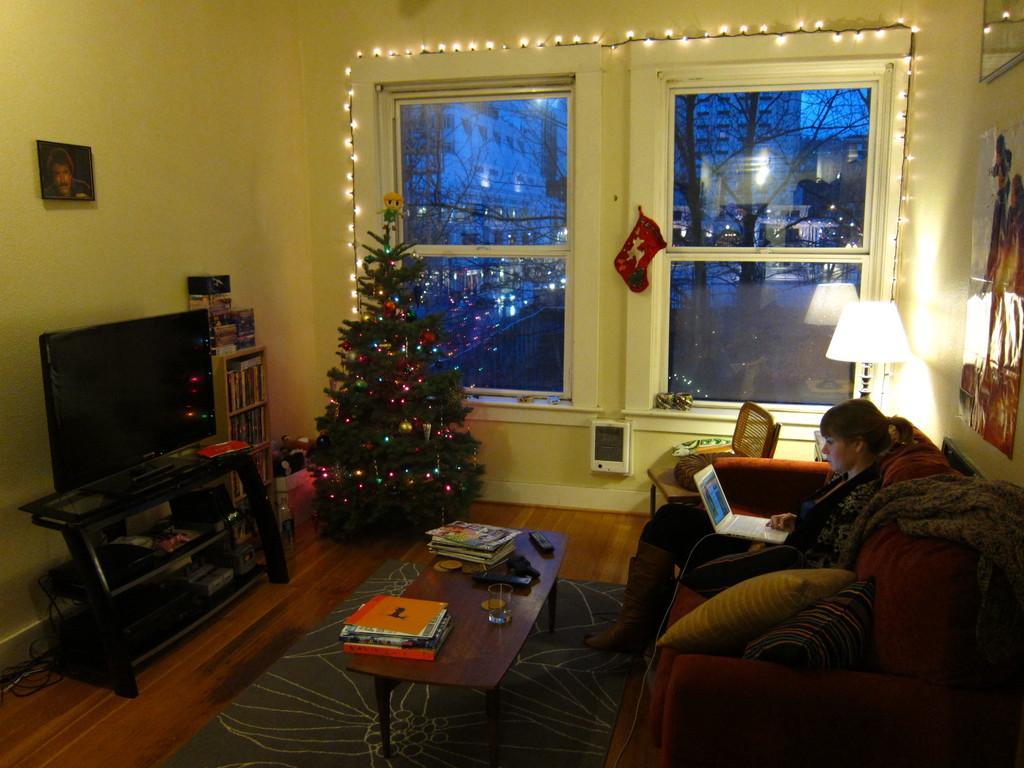Could you give a brief overview of what you see in this image? In the middle of the image there is a xmas tree. Bottom middle of the image there is a table, On the table there is a glass and there are some books. Top right side of the image there is a wall on the wall there are some frames. Bottom right side of the image there is couch, On the couch there is a woman sitting and looking in to a computer. Behind the couch there is a lamp. Top left side of the image there is a wall, On the wall there is a frame. Bottom left side of the image there is a table on the table there is a television. At the top of the image there is a window through the window we can see some trees and building. 